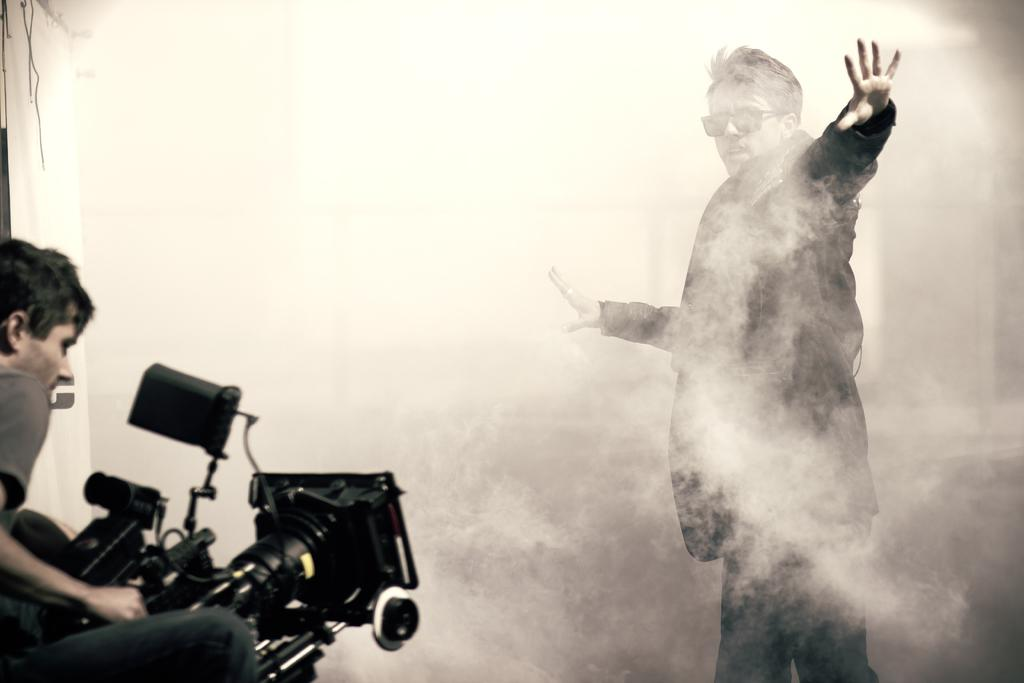What is the man in the image wearing on his upper body? The man is wearing a black jacket in the image. What is the man standing in? The man is standing in the smoke. What type of eye protection is the man wearing? The man is wearing goggles. What is the other man in the image doing? The other man is sitting and holding a video camera in his hand. What type of honey is being used to create the smoke in the image? There is no honey present in the image, and the smoke is not created by honey. 